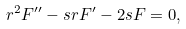<formula> <loc_0><loc_0><loc_500><loc_500>r ^ { 2 } F ^ { \prime \prime } - s r F ^ { \prime } - 2 s F = 0 ,</formula> 